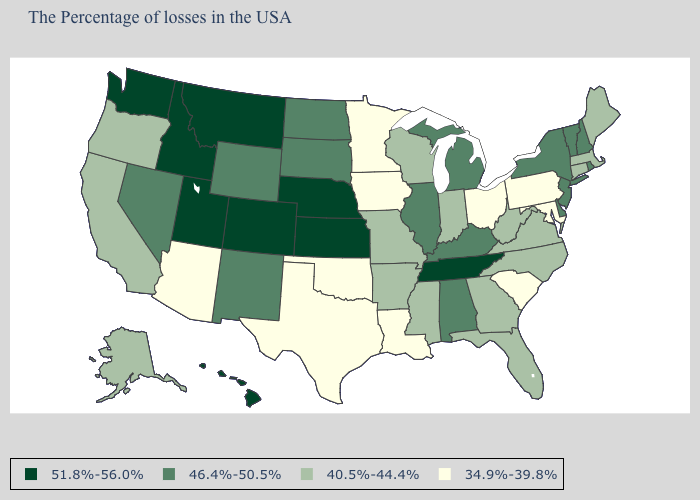What is the lowest value in the USA?
Be succinct. 34.9%-39.8%. What is the lowest value in the USA?
Quick response, please. 34.9%-39.8%. What is the highest value in the MidWest ?
Be succinct. 51.8%-56.0%. Among the states that border Maine , which have the highest value?
Concise answer only. New Hampshire. What is the value of Hawaii?
Be succinct. 51.8%-56.0%. Does the map have missing data?
Answer briefly. No. What is the value of Rhode Island?
Concise answer only. 46.4%-50.5%. What is the value of Minnesota?
Quick response, please. 34.9%-39.8%. Name the states that have a value in the range 34.9%-39.8%?
Write a very short answer. Maryland, Pennsylvania, South Carolina, Ohio, Louisiana, Minnesota, Iowa, Oklahoma, Texas, Arizona. Does Massachusetts have the same value as Arizona?
Keep it brief. No. What is the value of Oregon?
Short answer required. 40.5%-44.4%. Name the states that have a value in the range 34.9%-39.8%?
Answer briefly. Maryland, Pennsylvania, South Carolina, Ohio, Louisiana, Minnesota, Iowa, Oklahoma, Texas, Arizona. What is the highest value in the USA?
Write a very short answer. 51.8%-56.0%. Which states hav the highest value in the West?
Write a very short answer. Colorado, Utah, Montana, Idaho, Washington, Hawaii. 